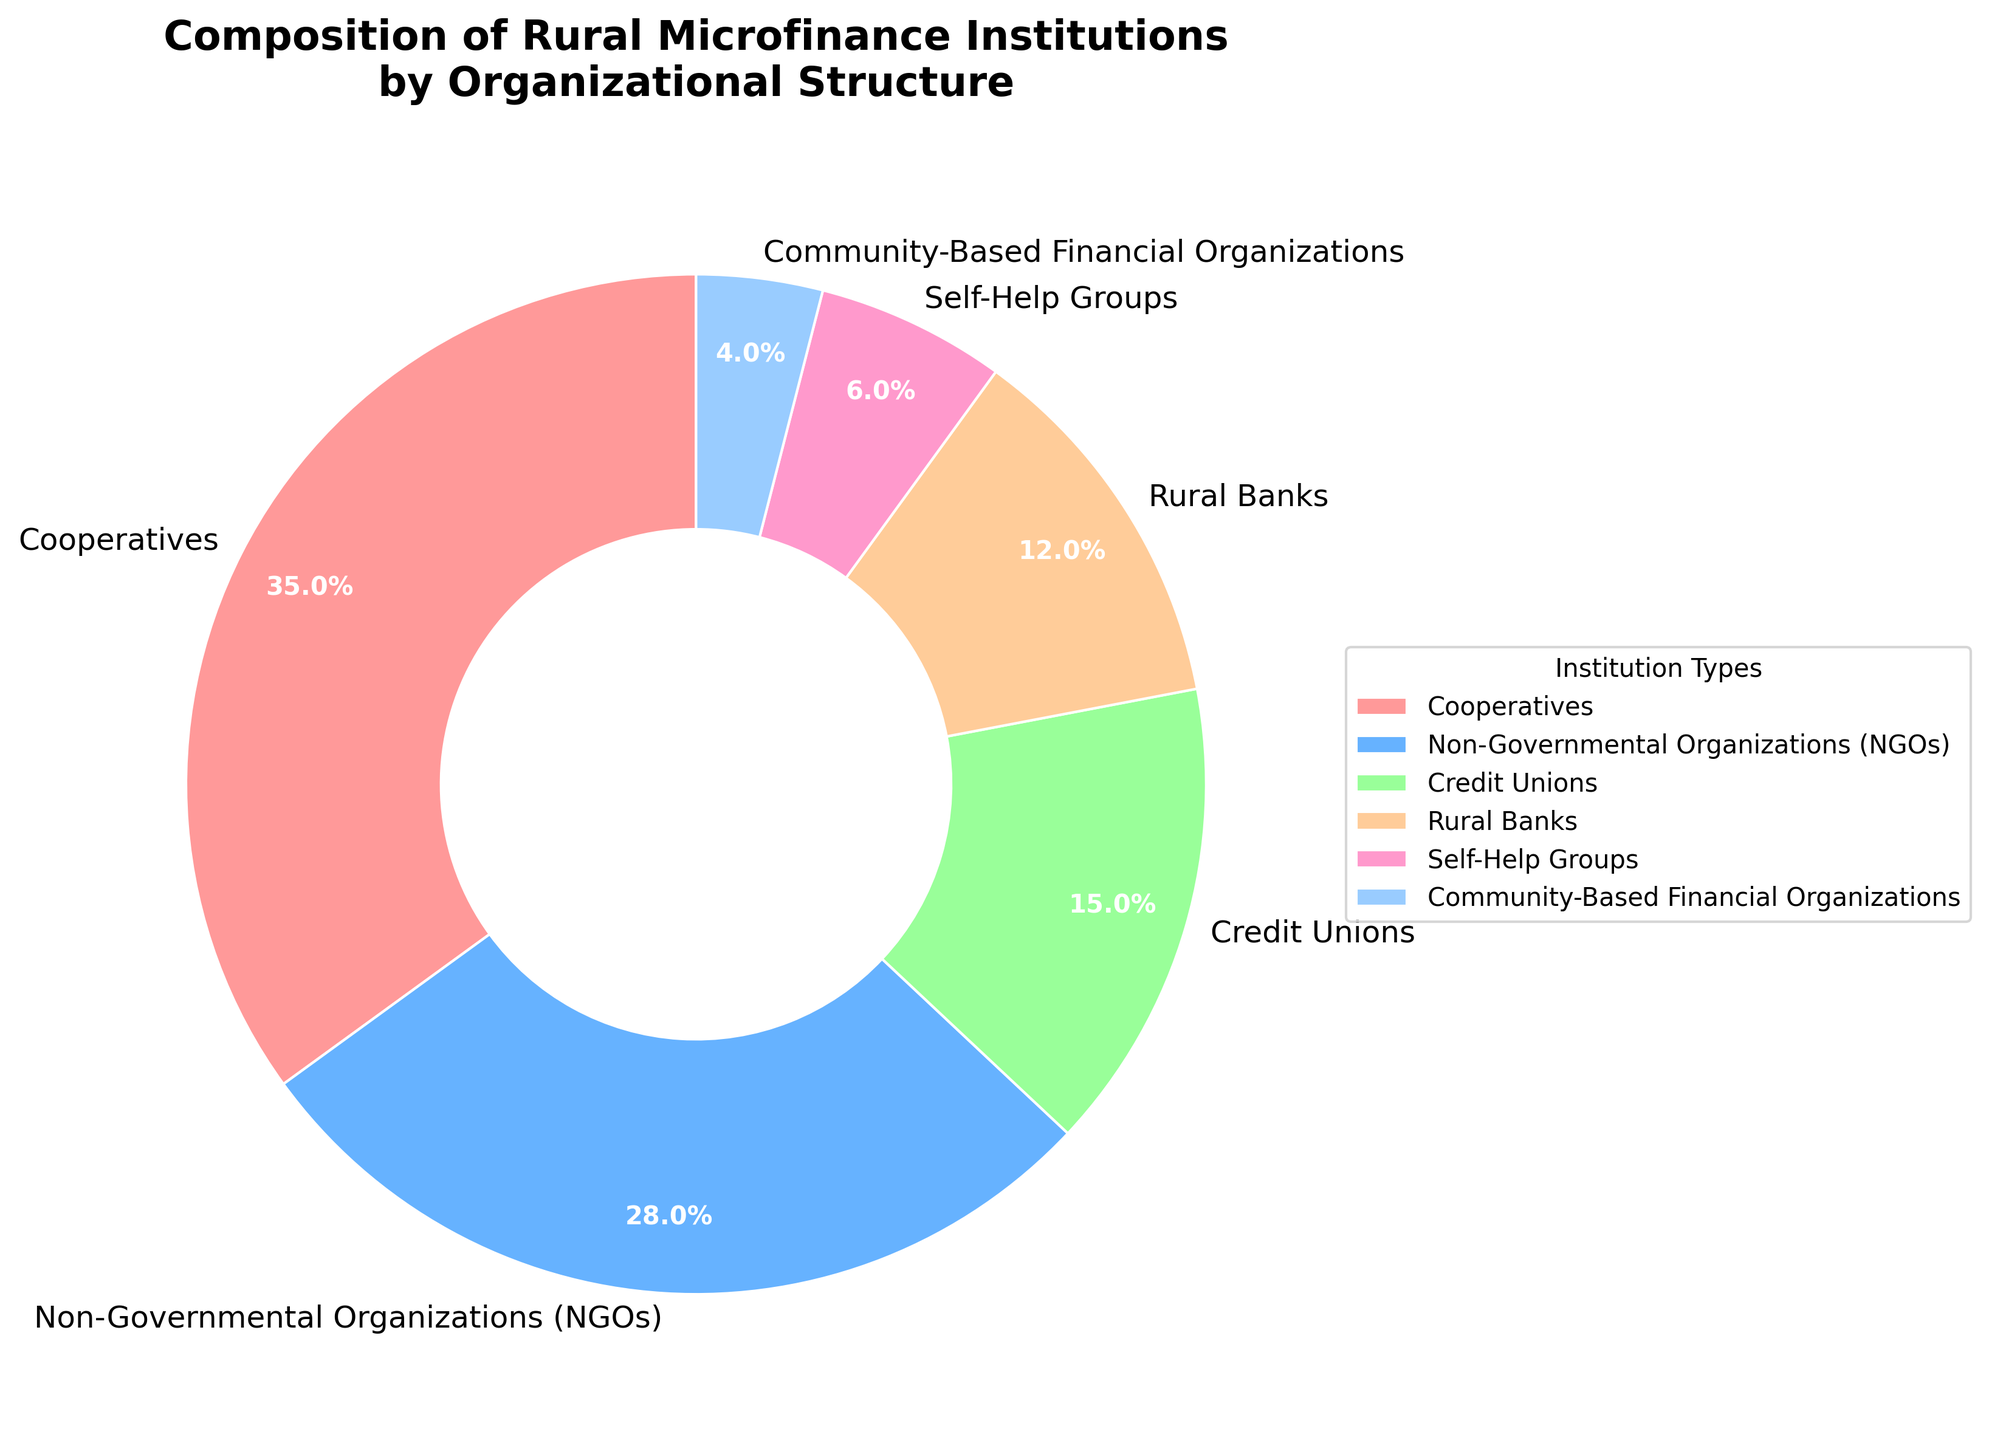Which organizational structure constitutes the largest share of rural microfinance institutions? Looking at the pie chart, the segment labeled "Cooperatives" occupies the largest area.
Answer: Cooperatives Which type of rural microfinance institution has the smallest share? The smallest segment is labeled "Community-Based Financial Organizations."
Answer: Community-Based Financial Organizations What is the combined percentage of NGOs and Rural Banks? NGOs account for 28%, and Rural Banks account for 12%. Adding these percentages together gives 28% + 12% = 40%.
Answer: 40% Are Credit Unions more prevalent than Self-Help Groups? The chart shows Credit Unions at 15% and Self-Help Groups at 6%. Since 15% is greater than 6%, Credit Unions are more prevalent.
Answer: Yes Which two types of institutions together make up more than half of the rural microfinance institutions? Cooperatives and NGOs contribute 35% and 28% respectively. Adding these gives 35% + 28% = 63%, which is more than half.
Answer: Cooperatives and NGOs How does the proportion of Rural Banks compare to that of Credit Unions? The chart lists Rural Banks at 12% and Credit Unions at 15%. Therefore, the proportion of Credit Unions is larger than Rural Banks.
Answer: Less than What percentage of the institutions are categorized as Self-Help Groups or Community-Based Financial Organizations? Self-Help Groups make up 6% and Community-Based Financial Organizations make up 4%. Adding these gives 6% + 4% = 10%.
Answer: 10% What is the difference in the percentage between Cooperatives and NGOs? Cooperatives account for 35%, and NGOs account for 28%. The difference is 35% - 28% = 7%.
Answer: 7% Which segment is represented by the green color in the pie chart? The green segment represents "Credit Unions," as observed in the color-coded pie chart.
Answer: Credit Unions 